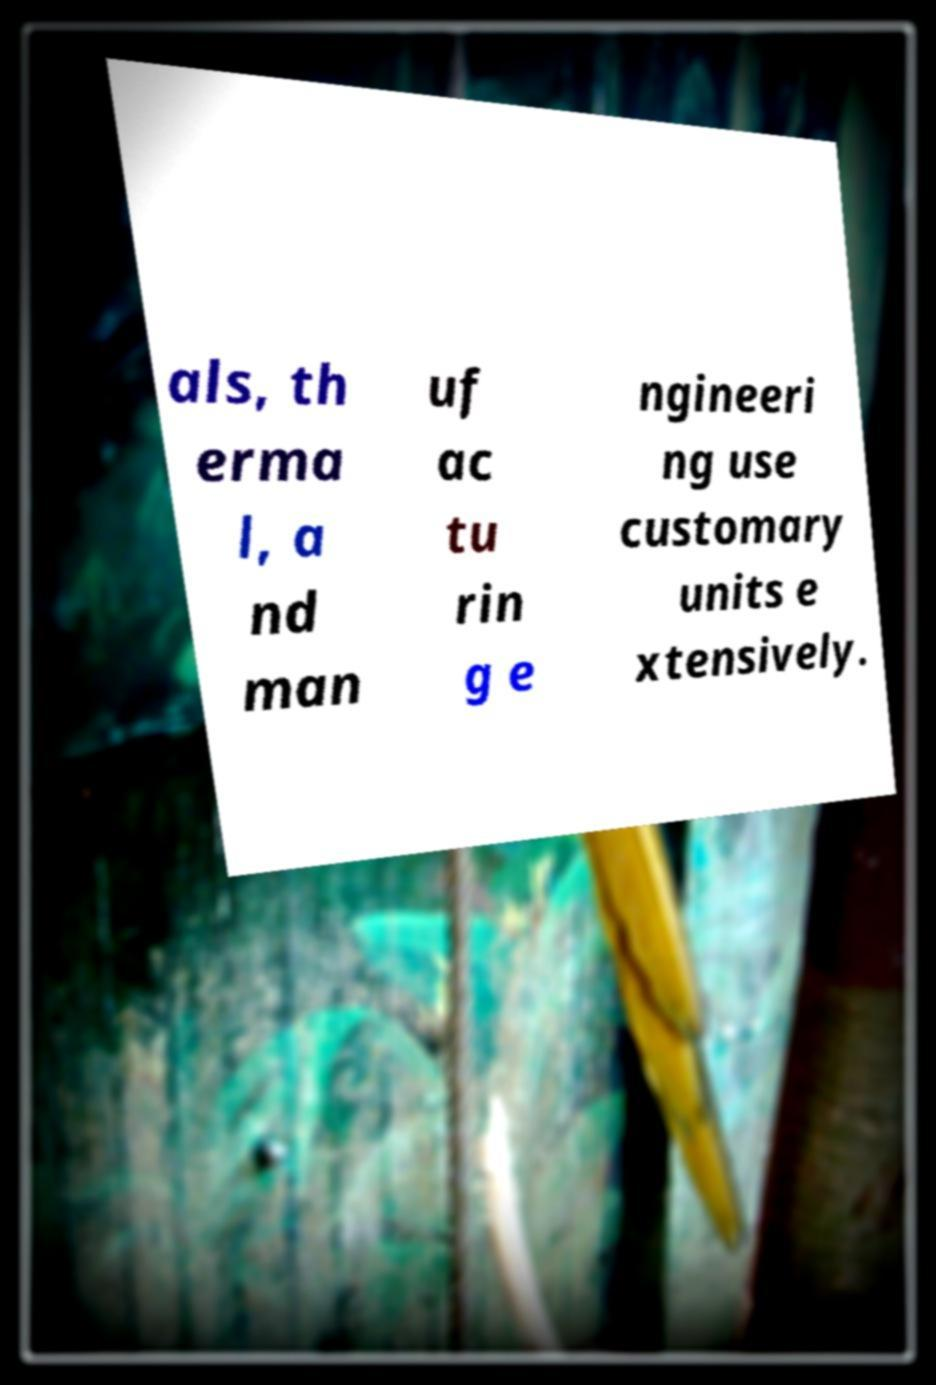For documentation purposes, I need the text within this image transcribed. Could you provide that? als, th erma l, a nd man uf ac tu rin g e ngineeri ng use customary units e xtensively. 